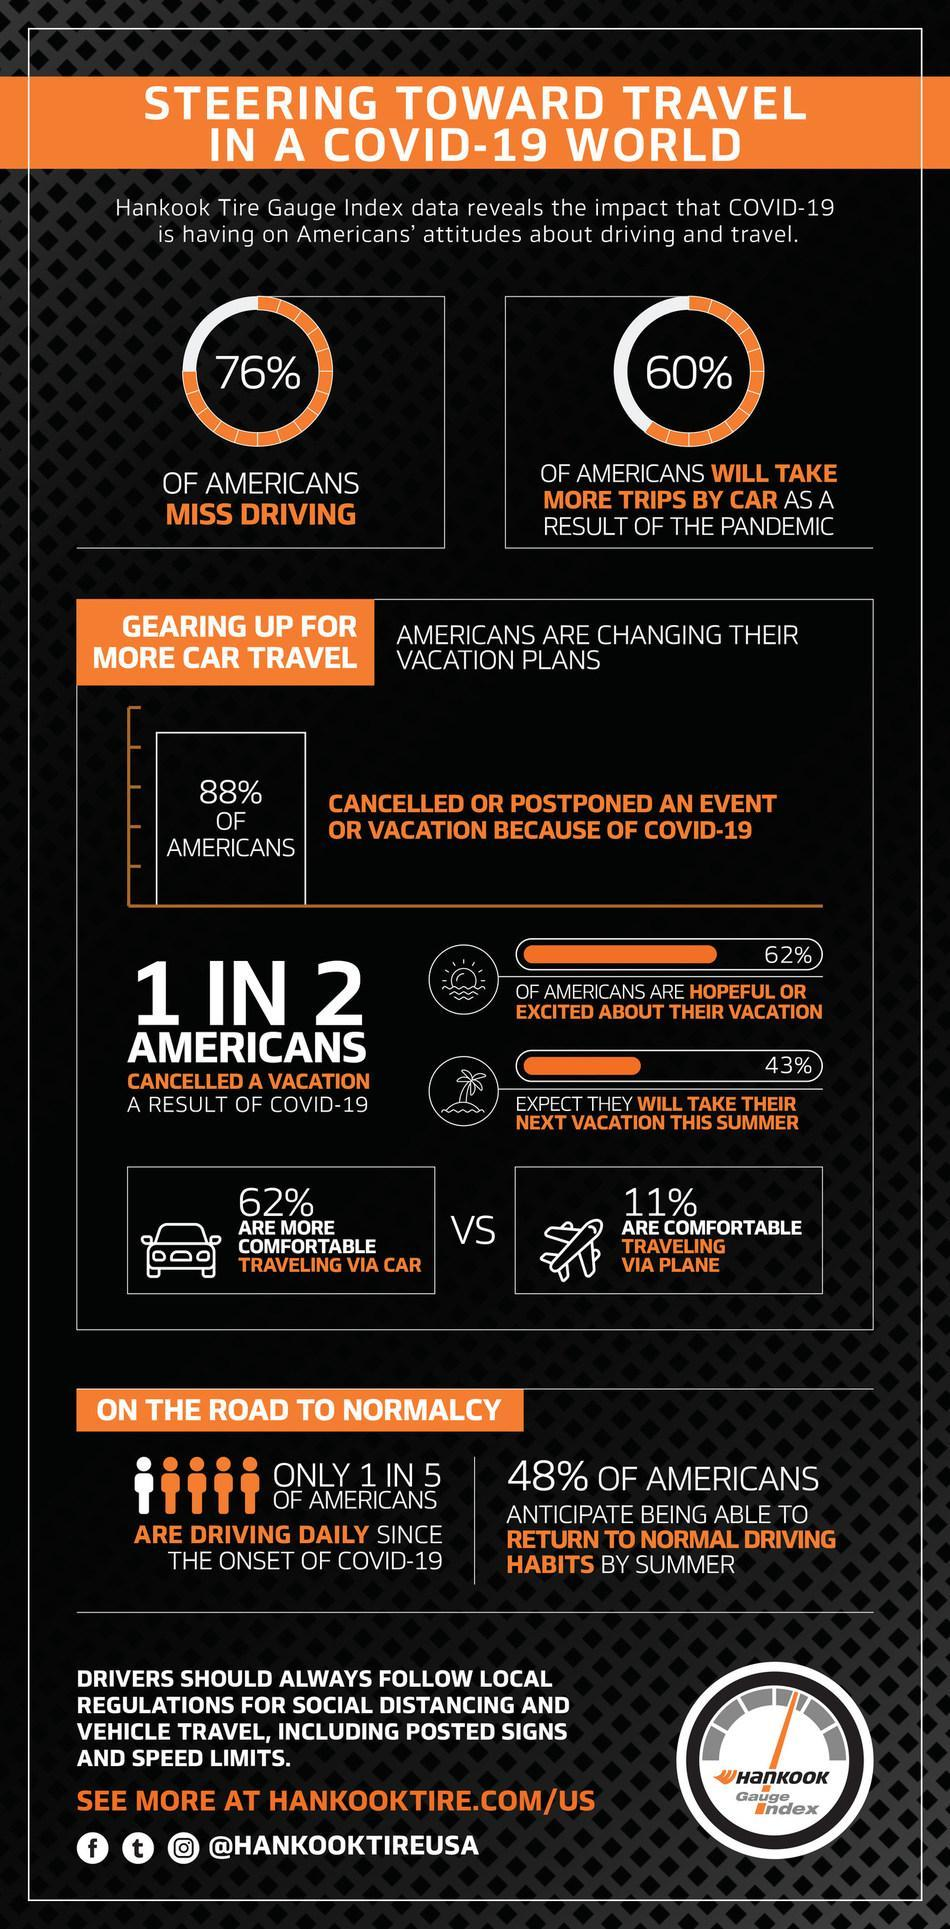What percentage of Americans are not missing driving?
Answer the question with a short phrase. 24% What percentage of people are not comfortable traveling via plane? 89% What percentage of Americans are not hopeful about their vacation? 38% What percentage of people are not comfortable traveling via car? 38% 